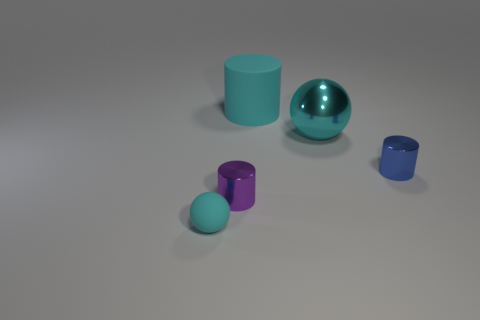Do the big thing right of the cyan cylinder and the matte sphere have the same color?
Provide a succinct answer. Yes. There is a big metal object that is behind the purple thing; is there a cyan sphere right of it?
Provide a succinct answer. No. What is the cyan object that is left of the large cyan metal thing and behind the tiny cyan ball made of?
Make the answer very short. Rubber. What shape is the tiny cyan object that is the same material as the cyan cylinder?
Your answer should be very brief. Sphere. Do the small thing in front of the purple cylinder and the blue cylinder have the same material?
Make the answer very short. No. There is a ball that is to the left of the purple cylinder; what material is it?
Provide a succinct answer. Rubber. How big is the blue metallic cylinder that is behind the rubber object in front of the purple cylinder?
Provide a succinct answer. Small. How many cyan cylinders are the same size as the shiny sphere?
Your answer should be very brief. 1. Do the big metallic sphere on the right side of the matte cylinder and the ball that is to the left of the large cyan cylinder have the same color?
Your answer should be compact. Yes. There is a cyan matte ball; are there any purple things to the right of it?
Your answer should be compact. Yes. 